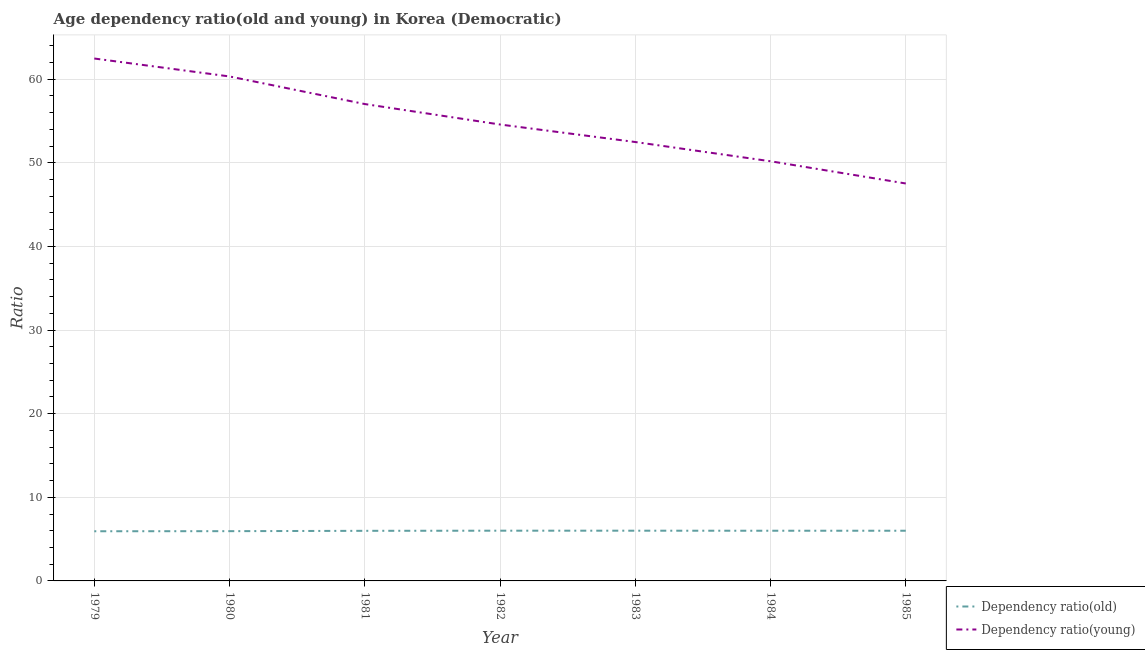How many different coloured lines are there?
Offer a terse response. 2. Does the line corresponding to age dependency ratio(old) intersect with the line corresponding to age dependency ratio(young)?
Keep it short and to the point. No. What is the age dependency ratio(old) in 1982?
Offer a very short reply. 6.01. Across all years, what is the maximum age dependency ratio(young)?
Your answer should be compact. 62.47. Across all years, what is the minimum age dependency ratio(old)?
Provide a short and direct response. 5.94. In which year was the age dependency ratio(young) maximum?
Ensure brevity in your answer.  1979. In which year was the age dependency ratio(young) minimum?
Provide a short and direct response. 1985. What is the total age dependency ratio(old) in the graph?
Make the answer very short. 41.89. What is the difference between the age dependency ratio(young) in 1979 and that in 1985?
Offer a terse response. 14.94. What is the difference between the age dependency ratio(young) in 1979 and the age dependency ratio(old) in 1983?
Your response must be concise. 56.46. What is the average age dependency ratio(young) per year?
Offer a very short reply. 54.94. In the year 1984, what is the difference between the age dependency ratio(old) and age dependency ratio(young)?
Your answer should be very brief. -44.18. What is the ratio of the age dependency ratio(young) in 1979 to that in 1981?
Make the answer very short. 1.1. Is the difference between the age dependency ratio(young) in 1979 and 1985 greater than the difference between the age dependency ratio(old) in 1979 and 1985?
Provide a short and direct response. Yes. What is the difference between the highest and the second highest age dependency ratio(young)?
Make the answer very short. 2.15. What is the difference between the highest and the lowest age dependency ratio(old)?
Your answer should be very brief. 0.07. Is the age dependency ratio(old) strictly less than the age dependency ratio(young) over the years?
Your answer should be compact. Yes. Are the values on the major ticks of Y-axis written in scientific E-notation?
Provide a succinct answer. No. Does the graph contain any zero values?
Offer a very short reply. No. Does the graph contain grids?
Offer a terse response. Yes. Where does the legend appear in the graph?
Your answer should be very brief. Bottom right. How many legend labels are there?
Your answer should be very brief. 2. What is the title of the graph?
Offer a terse response. Age dependency ratio(old and young) in Korea (Democratic). Does "Under five" appear as one of the legend labels in the graph?
Ensure brevity in your answer.  No. What is the label or title of the X-axis?
Ensure brevity in your answer.  Year. What is the label or title of the Y-axis?
Offer a very short reply. Ratio. What is the Ratio in Dependency ratio(old) in 1979?
Give a very brief answer. 5.94. What is the Ratio of Dependency ratio(young) in 1979?
Ensure brevity in your answer.  62.47. What is the Ratio in Dependency ratio(old) in 1980?
Offer a terse response. 5.95. What is the Ratio in Dependency ratio(young) in 1980?
Provide a succinct answer. 60.32. What is the Ratio of Dependency ratio(old) in 1981?
Your answer should be compact. 5.99. What is the Ratio of Dependency ratio(young) in 1981?
Make the answer very short. 57.02. What is the Ratio in Dependency ratio(old) in 1982?
Offer a terse response. 6.01. What is the Ratio in Dependency ratio(young) in 1982?
Provide a short and direct response. 54.57. What is the Ratio of Dependency ratio(old) in 1983?
Give a very brief answer. 6.01. What is the Ratio in Dependency ratio(young) in 1983?
Provide a short and direct response. 52.48. What is the Ratio in Dependency ratio(old) in 1984?
Offer a terse response. 6. What is the Ratio in Dependency ratio(young) in 1984?
Your response must be concise. 50.18. What is the Ratio in Dependency ratio(old) in 1985?
Your answer should be compact. 6. What is the Ratio in Dependency ratio(young) in 1985?
Your response must be concise. 47.52. Across all years, what is the maximum Ratio in Dependency ratio(old)?
Offer a terse response. 6.01. Across all years, what is the maximum Ratio of Dependency ratio(young)?
Make the answer very short. 62.47. Across all years, what is the minimum Ratio of Dependency ratio(old)?
Keep it short and to the point. 5.94. Across all years, what is the minimum Ratio in Dependency ratio(young)?
Keep it short and to the point. 47.52. What is the total Ratio in Dependency ratio(old) in the graph?
Give a very brief answer. 41.89. What is the total Ratio of Dependency ratio(young) in the graph?
Provide a short and direct response. 384.56. What is the difference between the Ratio of Dependency ratio(old) in 1979 and that in 1980?
Your response must be concise. -0.01. What is the difference between the Ratio of Dependency ratio(young) in 1979 and that in 1980?
Provide a short and direct response. 2.15. What is the difference between the Ratio of Dependency ratio(old) in 1979 and that in 1981?
Your answer should be very brief. -0.05. What is the difference between the Ratio in Dependency ratio(young) in 1979 and that in 1981?
Offer a very short reply. 5.45. What is the difference between the Ratio in Dependency ratio(old) in 1979 and that in 1982?
Your answer should be very brief. -0.07. What is the difference between the Ratio in Dependency ratio(young) in 1979 and that in 1982?
Provide a short and direct response. 7.89. What is the difference between the Ratio of Dependency ratio(old) in 1979 and that in 1983?
Ensure brevity in your answer.  -0.07. What is the difference between the Ratio in Dependency ratio(young) in 1979 and that in 1983?
Keep it short and to the point. 9.99. What is the difference between the Ratio of Dependency ratio(old) in 1979 and that in 1984?
Make the answer very short. -0.06. What is the difference between the Ratio in Dependency ratio(young) in 1979 and that in 1984?
Provide a succinct answer. 12.29. What is the difference between the Ratio of Dependency ratio(old) in 1979 and that in 1985?
Your answer should be compact. -0.06. What is the difference between the Ratio in Dependency ratio(young) in 1979 and that in 1985?
Keep it short and to the point. 14.94. What is the difference between the Ratio of Dependency ratio(old) in 1980 and that in 1981?
Your response must be concise. -0.04. What is the difference between the Ratio of Dependency ratio(young) in 1980 and that in 1981?
Your response must be concise. 3.3. What is the difference between the Ratio in Dependency ratio(old) in 1980 and that in 1982?
Keep it short and to the point. -0.06. What is the difference between the Ratio in Dependency ratio(young) in 1980 and that in 1982?
Offer a very short reply. 5.75. What is the difference between the Ratio in Dependency ratio(old) in 1980 and that in 1983?
Offer a very short reply. -0.06. What is the difference between the Ratio of Dependency ratio(young) in 1980 and that in 1983?
Provide a succinct answer. 7.84. What is the difference between the Ratio in Dependency ratio(old) in 1980 and that in 1984?
Keep it short and to the point. -0.05. What is the difference between the Ratio in Dependency ratio(young) in 1980 and that in 1984?
Offer a terse response. 10.14. What is the difference between the Ratio in Dependency ratio(old) in 1980 and that in 1985?
Make the answer very short. -0.05. What is the difference between the Ratio in Dependency ratio(young) in 1980 and that in 1985?
Give a very brief answer. 12.8. What is the difference between the Ratio of Dependency ratio(old) in 1981 and that in 1982?
Offer a terse response. -0.02. What is the difference between the Ratio in Dependency ratio(young) in 1981 and that in 1982?
Your response must be concise. 2.45. What is the difference between the Ratio of Dependency ratio(old) in 1981 and that in 1983?
Offer a terse response. -0.01. What is the difference between the Ratio of Dependency ratio(young) in 1981 and that in 1983?
Offer a terse response. 4.54. What is the difference between the Ratio in Dependency ratio(old) in 1981 and that in 1984?
Your answer should be very brief. -0.01. What is the difference between the Ratio of Dependency ratio(young) in 1981 and that in 1984?
Offer a terse response. 6.84. What is the difference between the Ratio of Dependency ratio(old) in 1981 and that in 1985?
Make the answer very short. -0.01. What is the difference between the Ratio in Dependency ratio(young) in 1981 and that in 1985?
Provide a succinct answer. 9.5. What is the difference between the Ratio in Dependency ratio(old) in 1982 and that in 1983?
Your response must be concise. 0. What is the difference between the Ratio of Dependency ratio(young) in 1982 and that in 1983?
Provide a short and direct response. 2.09. What is the difference between the Ratio in Dependency ratio(old) in 1982 and that in 1984?
Keep it short and to the point. 0.01. What is the difference between the Ratio of Dependency ratio(young) in 1982 and that in 1984?
Your answer should be compact. 4.4. What is the difference between the Ratio of Dependency ratio(old) in 1982 and that in 1985?
Provide a short and direct response. 0.01. What is the difference between the Ratio of Dependency ratio(young) in 1982 and that in 1985?
Your answer should be very brief. 7.05. What is the difference between the Ratio in Dependency ratio(old) in 1983 and that in 1984?
Keep it short and to the point. 0.01. What is the difference between the Ratio in Dependency ratio(young) in 1983 and that in 1984?
Make the answer very short. 2.3. What is the difference between the Ratio of Dependency ratio(old) in 1983 and that in 1985?
Offer a terse response. 0.01. What is the difference between the Ratio in Dependency ratio(young) in 1983 and that in 1985?
Provide a short and direct response. 4.96. What is the difference between the Ratio of Dependency ratio(old) in 1984 and that in 1985?
Keep it short and to the point. -0. What is the difference between the Ratio in Dependency ratio(young) in 1984 and that in 1985?
Your answer should be compact. 2.66. What is the difference between the Ratio in Dependency ratio(old) in 1979 and the Ratio in Dependency ratio(young) in 1980?
Provide a short and direct response. -54.38. What is the difference between the Ratio in Dependency ratio(old) in 1979 and the Ratio in Dependency ratio(young) in 1981?
Ensure brevity in your answer.  -51.08. What is the difference between the Ratio of Dependency ratio(old) in 1979 and the Ratio of Dependency ratio(young) in 1982?
Your response must be concise. -48.64. What is the difference between the Ratio of Dependency ratio(old) in 1979 and the Ratio of Dependency ratio(young) in 1983?
Ensure brevity in your answer.  -46.54. What is the difference between the Ratio of Dependency ratio(old) in 1979 and the Ratio of Dependency ratio(young) in 1984?
Provide a short and direct response. -44.24. What is the difference between the Ratio in Dependency ratio(old) in 1979 and the Ratio in Dependency ratio(young) in 1985?
Give a very brief answer. -41.58. What is the difference between the Ratio of Dependency ratio(old) in 1980 and the Ratio of Dependency ratio(young) in 1981?
Give a very brief answer. -51.07. What is the difference between the Ratio of Dependency ratio(old) in 1980 and the Ratio of Dependency ratio(young) in 1982?
Keep it short and to the point. -48.63. What is the difference between the Ratio in Dependency ratio(old) in 1980 and the Ratio in Dependency ratio(young) in 1983?
Provide a short and direct response. -46.53. What is the difference between the Ratio of Dependency ratio(old) in 1980 and the Ratio of Dependency ratio(young) in 1984?
Keep it short and to the point. -44.23. What is the difference between the Ratio of Dependency ratio(old) in 1980 and the Ratio of Dependency ratio(young) in 1985?
Make the answer very short. -41.57. What is the difference between the Ratio in Dependency ratio(old) in 1981 and the Ratio in Dependency ratio(young) in 1982?
Your answer should be very brief. -48.58. What is the difference between the Ratio of Dependency ratio(old) in 1981 and the Ratio of Dependency ratio(young) in 1983?
Provide a succinct answer. -46.49. What is the difference between the Ratio of Dependency ratio(old) in 1981 and the Ratio of Dependency ratio(young) in 1984?
Offer a very short reply. -44.19. What is the difference between the Ratio of Dependency ratio(old) in 1981 and the Ratio of Dependency ratio(young) in 1985?
Your answer should be compact. -41.53. What is the difference between the Ratio of Dependency ratio(old) in 1982 and the Ratio of Dependency ratio(young) in 1983?
Offer a terse response. -46.47. What is the difference between the Ratio of Dependency ratio(old) in 1982 and the Ratio of Dependency ratio(young) in 1984?
Your answer should be very brief. -44.17. What is the difference between the Ratio in Dependency ratio(old) in 1982 and the Ratio in Dependency ratio(young) in 1985?
Keep it short and to the point. -41.52. What is the difference between the Ratio in Dependency ratio(old) in 1983 and the Ratio in Dependency ratio(young) in 1984?
Provide a succinct answer. -44.17. What is the difference between the Ratio in Dependency ratio(old) in 1983 and the Ratio in Dependency ratio(young) in 1985?
Provide a short and direct response. -41.52. What is the difference between the Ratio of Dependency ratio(old) in 1984 and the Ratio of Dependency ratio(young) in 1985?
Offer a terse response. -41.52. What is the average Ratio in Dependency ratio(old) per year?
Ensure brevity in your answer.  5.98. What is the average Ratio in Dependency ratio(young) per year?
Provide a short and direct response. 54.94. In the year 1979, what is the difference between the Ratio in Dependency ratio(old) and Ratio in Dependency ratio(young)?
Provide a short and direct response. -56.53. In the year 1980, what is the difference between the Ratio of Dependency ratio(old) and Ratio of Dependency ratio(young)?
Your answer should be very brief. -54.37. In the year 1981, what is the difference between the Ratio in Dependency ratio(old) and Ratio in Dependency ratio(young)?
Provide a short and direct response. -51.03. In the year 1982, what is the difference between the Ratio of Dependency ratio(old) and Ratio of Dependency ratio(young)?
Your response must be concise. -48.57. In the year 1983, what is the difference between the Ratio in Dependency ratio(old) and Ratio in Dependency ratio(young)?
Provide a short and direct response. -46.47. In the year 1984, what is the difference between the Ratio of Dependency ratio(old) and Ratio of Dependency ratio(young)?
Ensure brevity in your answer.  -44.18. In the year 1985, what is the difference between the Ratio of Dependency ratio(old) and Ratio of Dependency ratio(young)?
Provide a succinct answer. -41.52. What is the ratio of the Ratio of Dependency ratio(young) in 1979 to that in 1980?
Provide a succinct answer. 1.04. What is the ratio of the Ratio in Dependency ratio(old) in 1979 to that in 1981?
Offer a terse response. 0.99. What is the ratio of the Ratio of Dependency ratio(young) in 1979 to that in 1981?
Make the answer very short. 1.1. What is the ratio of the Ratio in Dependency ratio(old) in 1979 to that in 1982?
Offer a very short reply. 0.99. What is the ratio of the Ratio of Dependency ratio(young) in 1979 to that in 1982?
Your response must be concise. 1.14. What is the ratio of the Ratio of Dependency ratio(old) in 1979 to that in 1983?
Your answer should be very brief. 0.99. What is the ratio of the Ratio of Dependency ratio(young) in 1979 to that in 1983?
Make the answer very short. 1.19. What is the ratio of the Ratio of Dependency ratio(old) in 1979 to that in 1984?
Offer a terse response. 0.99. What is the ratio of the Ratio in Dependency ratio(young) in 1979 to that in 1984?
Keep it short and to the point. 1.24. What is the ratio of the Ratio of Dependency ratio(old) in 1979 to that in 1985?
Provide a succinct answer. 0.99. What is the ratio of the Ratio of Dependency ratio(young) in 1979 to that in 1985?
Make the answer very short. 1.31. What is the ratio of the Ratio of Dependency ratio(young) in 1980 to that in 1981?
Give a very brief answer. 1.06. What is the ratio of the Ratio of Dependency ratio(old) in 1980 to that in 1982?
Your answer should be very brief. 0.99. What is the ratio of the Ratio in Dependency ratio(young) in 1980 to that in 1982?
Give a very brief answer. 1.11. What is the ratio of the Ratio in Dependency ratio(young) in 1980 to that in 1983?
Keep it short and to the point. 1.15. What is the ratio of the Ratio of Dependency ratio(young) in 1980 to that in 1984?
Keep it short and to the point. 1.2. What is the ratio of the Ratio in Dependency ratio(old) in 1980 to that in 1985?
Ensure brevity in your answer.  0.99. What is the ratio of the Ratio in Dependency ratio(young) in 1980 to that in 1985?
Keep it short and to the point. 1.27. What is the ratio of the Ratio of Dependency ratio(old) in 1981 to that in 1982?
Your response must be concise. 1. What is the ratio of the Ratio in Dependency ratio(young) in 1981 to that in 1982?
Your response must be concise. 1.04. What is the ratio of the Ratio of Dependency ratio(old) in 1981 to that in 1983?
Offer a terse response. 1. What is the ratio of the Ratio of Dependency ratio(young) in 1981 to that in 1983?
Ensure brevity in your answer.  1.09. What is the ratio of the Ratio in Dependency ratio(young) in 1981 to that in 1984?
Offer a terse response. 1.14. What is the ratio of the Ratio of Dependency ratio(young) in 1981 to that in 1985?
Keep it short and to the point. 1.2. What is the ratio of the Ratio in Dependency ratio(old) in 1982 to that in 1983?
Ensure brevity in your answer.  1. What is the ratio of the Ratio in Dependency ratio(young) in 1982 to that in 1983?
Provide a succinct answer. 1.04. What is the ratio of the Ratio of Dependency ratio(old) in 1982 to that in 1984?
Provide a short and direct response. 1. What is the ratio of the Ratio of Dependency ratio(young) in 1982 to that in 1984?
Provide a short and direct response. 1.09. What is the ratio of the Ratio of Dependency ratio(old) in 1982 to that in 1985?
Offer a very short reply. 1. What is the ratio of the Ratio of Dependency ratio(young) in 1982 to that in 1985?
Keep it short and to the point. 1.15. What is the ratio of the Ratio of Dependency ratio(old) in 1983 to that in 1984?
Your answer should be compact. 1. What is the ratio of the Ratio in Dependency ratio(young) in 1983 to that in 1984?
Your answer should be compact. 1.05. What is the ratio of the Ratio in Dependency ratio(young) in 1983 to that in 1985?
Give a very brief answer. 1.1. What is the ratio of the Ratio in Dependency ratio(old) in 1984 to that in 1985?
Ensure brevity in your answer.  1. What is the ratio of the Ratio of Dependency ratio(young) in 1984 to that in 1985?
Your response must be concise. 1.06. What is the difference between the highest and the second highest Ratio of Dependency ratio(old)?
Make the answer very short. 0. What is the difference between the highest and the second highest Ratio of Dependency ratio(young)?
Offer a very short reply. 2.15. What is the difference between the highest and the lowest Ratio of Dependency ratio(old)?
Give a very brief answer. 0.07. What is the difference between the highest and the lowest Ratio in Dependency ratio(young)?
Keep it short and to the point. 14.94. 